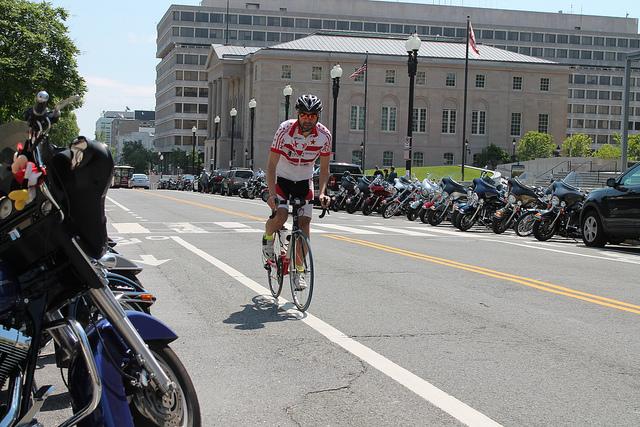What are the people riding?
Answer briefly. Bicycle. What is protecting his head?
Concise answer only. Helmet. How many flags are in the picture?
Write a very short answer. 1. What is the man riding?
Be succinct. Bike. 